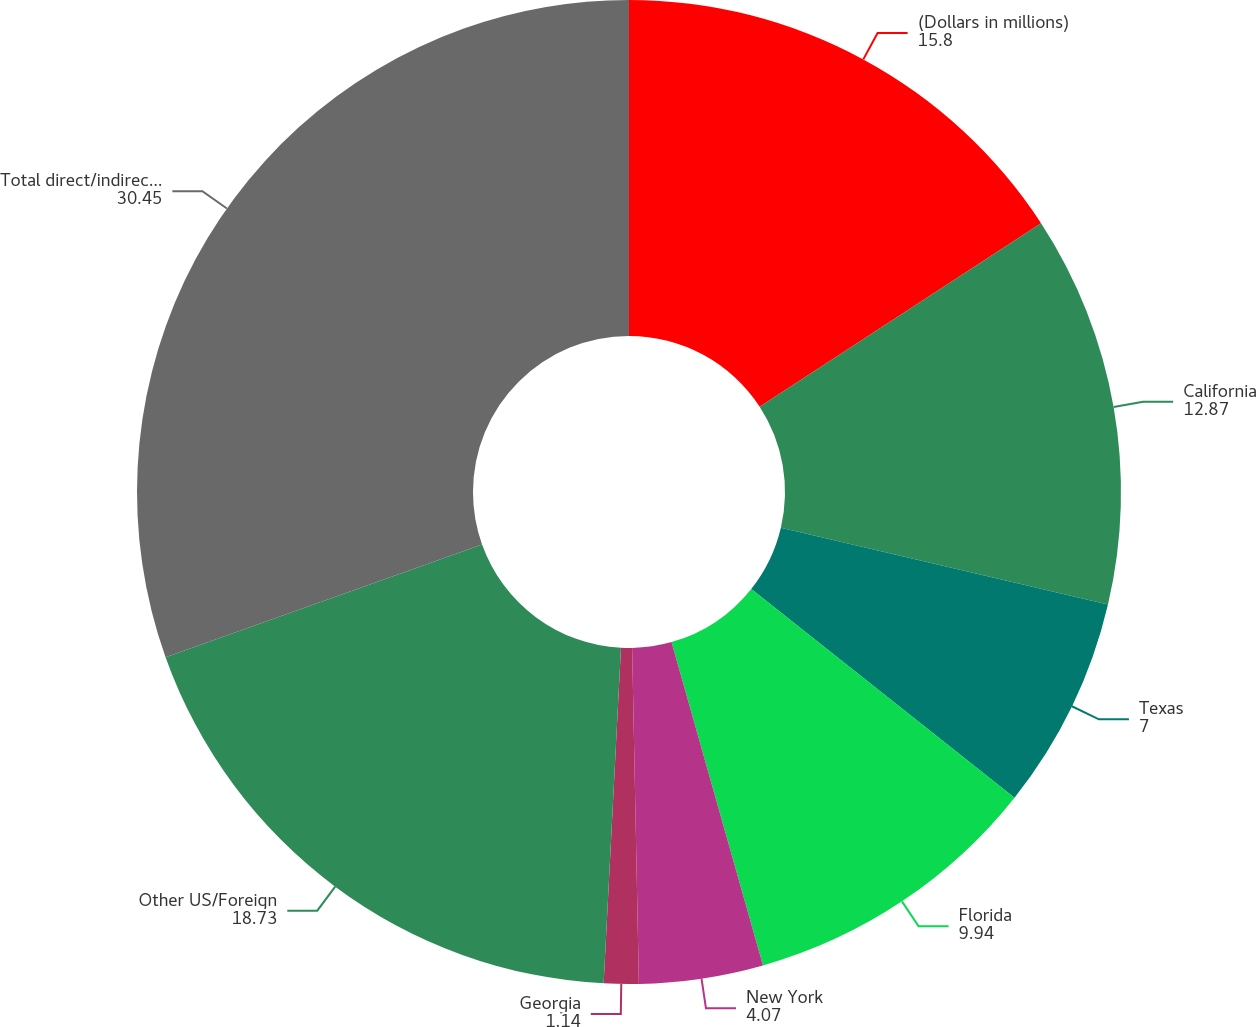Convert chart to OTSL. <chart><loc_0><loc_0><loc_500><loc_500><pie_chart><fcel>(Dollars in millions)<fcel>California<fcel>Texas<fcel>Florida<fcel>New York<fcel>Georgia<fcel>Other US/Foreign<fcel>Total direct/indirect loans<nl><fcel>15.8%<fcel>12.87%<fcel>7.0%<fcel>9.94%<fcel>4.07%<fcel>1.14%<fcel>18.73%<fcel>30.45%<nl></chart> 